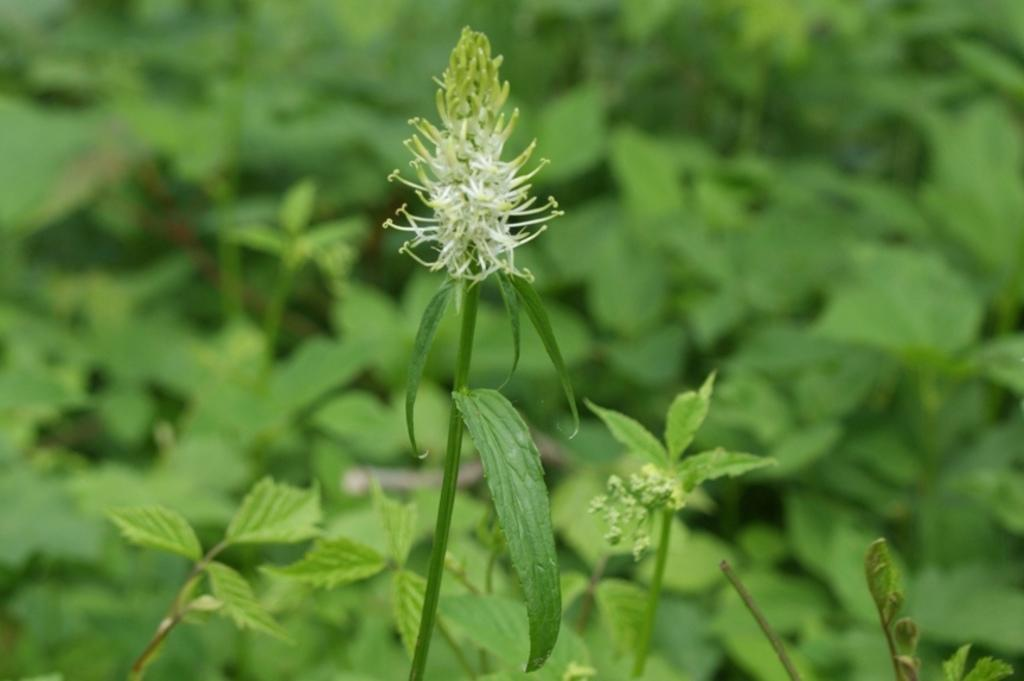What type of living organisms can be seen in the image? Plants can be seen in the image. What type of street is visible in the image? There is no street visible in the image; it only features plants. How many chickens can be seen in the image? There are no chickens present in the image. 